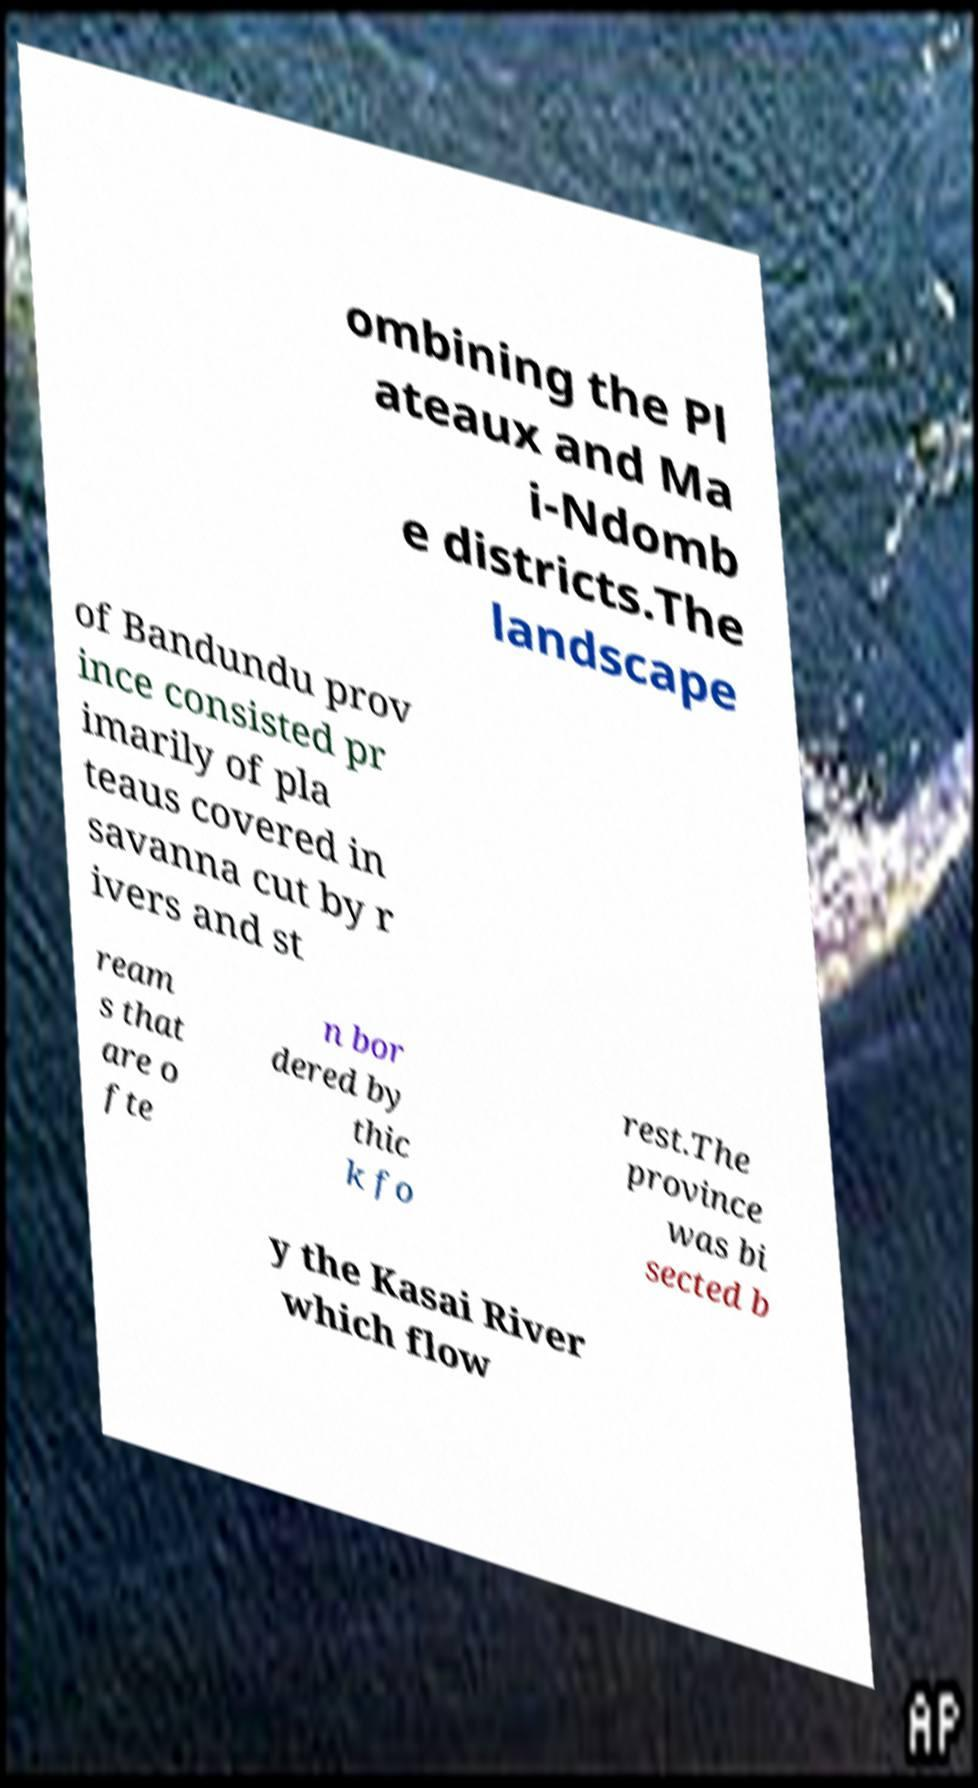Can you accurately transcribe the text from the provided image for me? ombining the Pl ateaux and Ma i-Ndomb e districts.The landscape of Bandundu prov ince consisted pr imarily of pla teaus covered in savanna cut by r ivers and st ream s that are o fte n bor dered by thic k fo rest.The province was bi sected b y the Kasai River which flow 